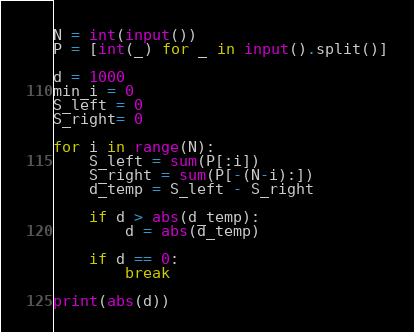<code> <loc_0><loc_0><loc_500><loc_500><_Python_>N = int(input())
P = [int(_) for _ in input().split()]

d = 1000
min_i = 0
S_left = 0
S_right= 0

for i in range(N):
    S_left = sum(P[:i])
    S_right = sum(P[-(N-i):])
    d_temp = S_left - S_right
    
    if d > abs(d_temp):
        d = abs(d_temp)

    if d == 0:
        break

print(abs(d))
</code> 